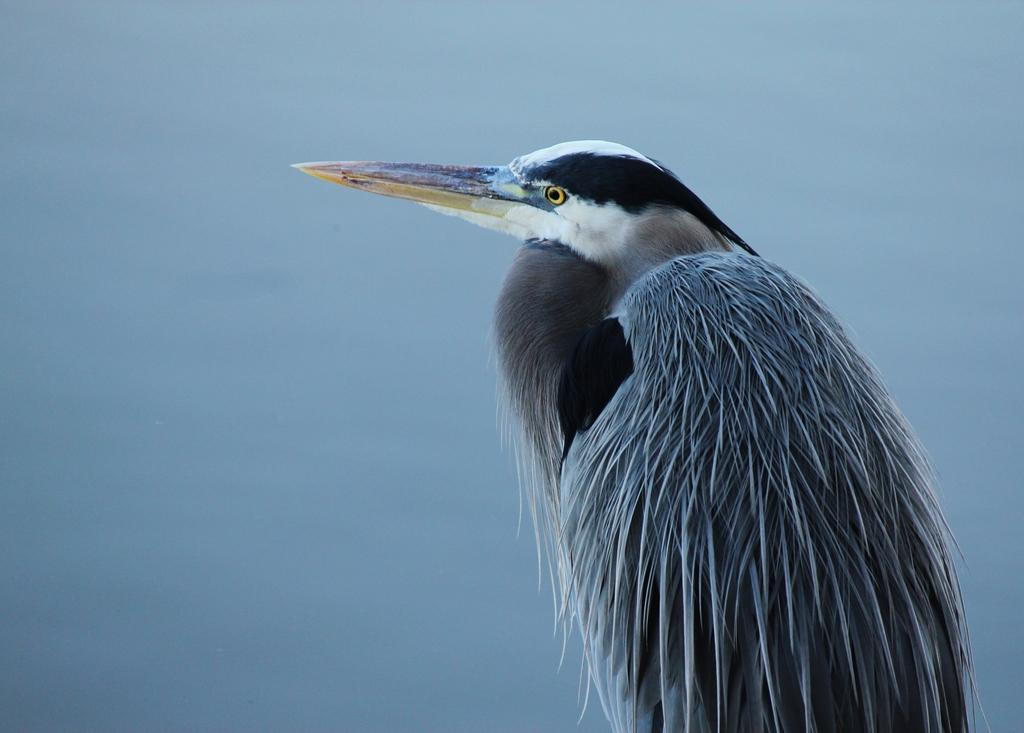What type of bird can be seen in the image? There is a black and brown color bird in the image. Can you describe the background of the image? The background of the image is blurred. What shape is the tent in the image? There is no tent present in the image. 